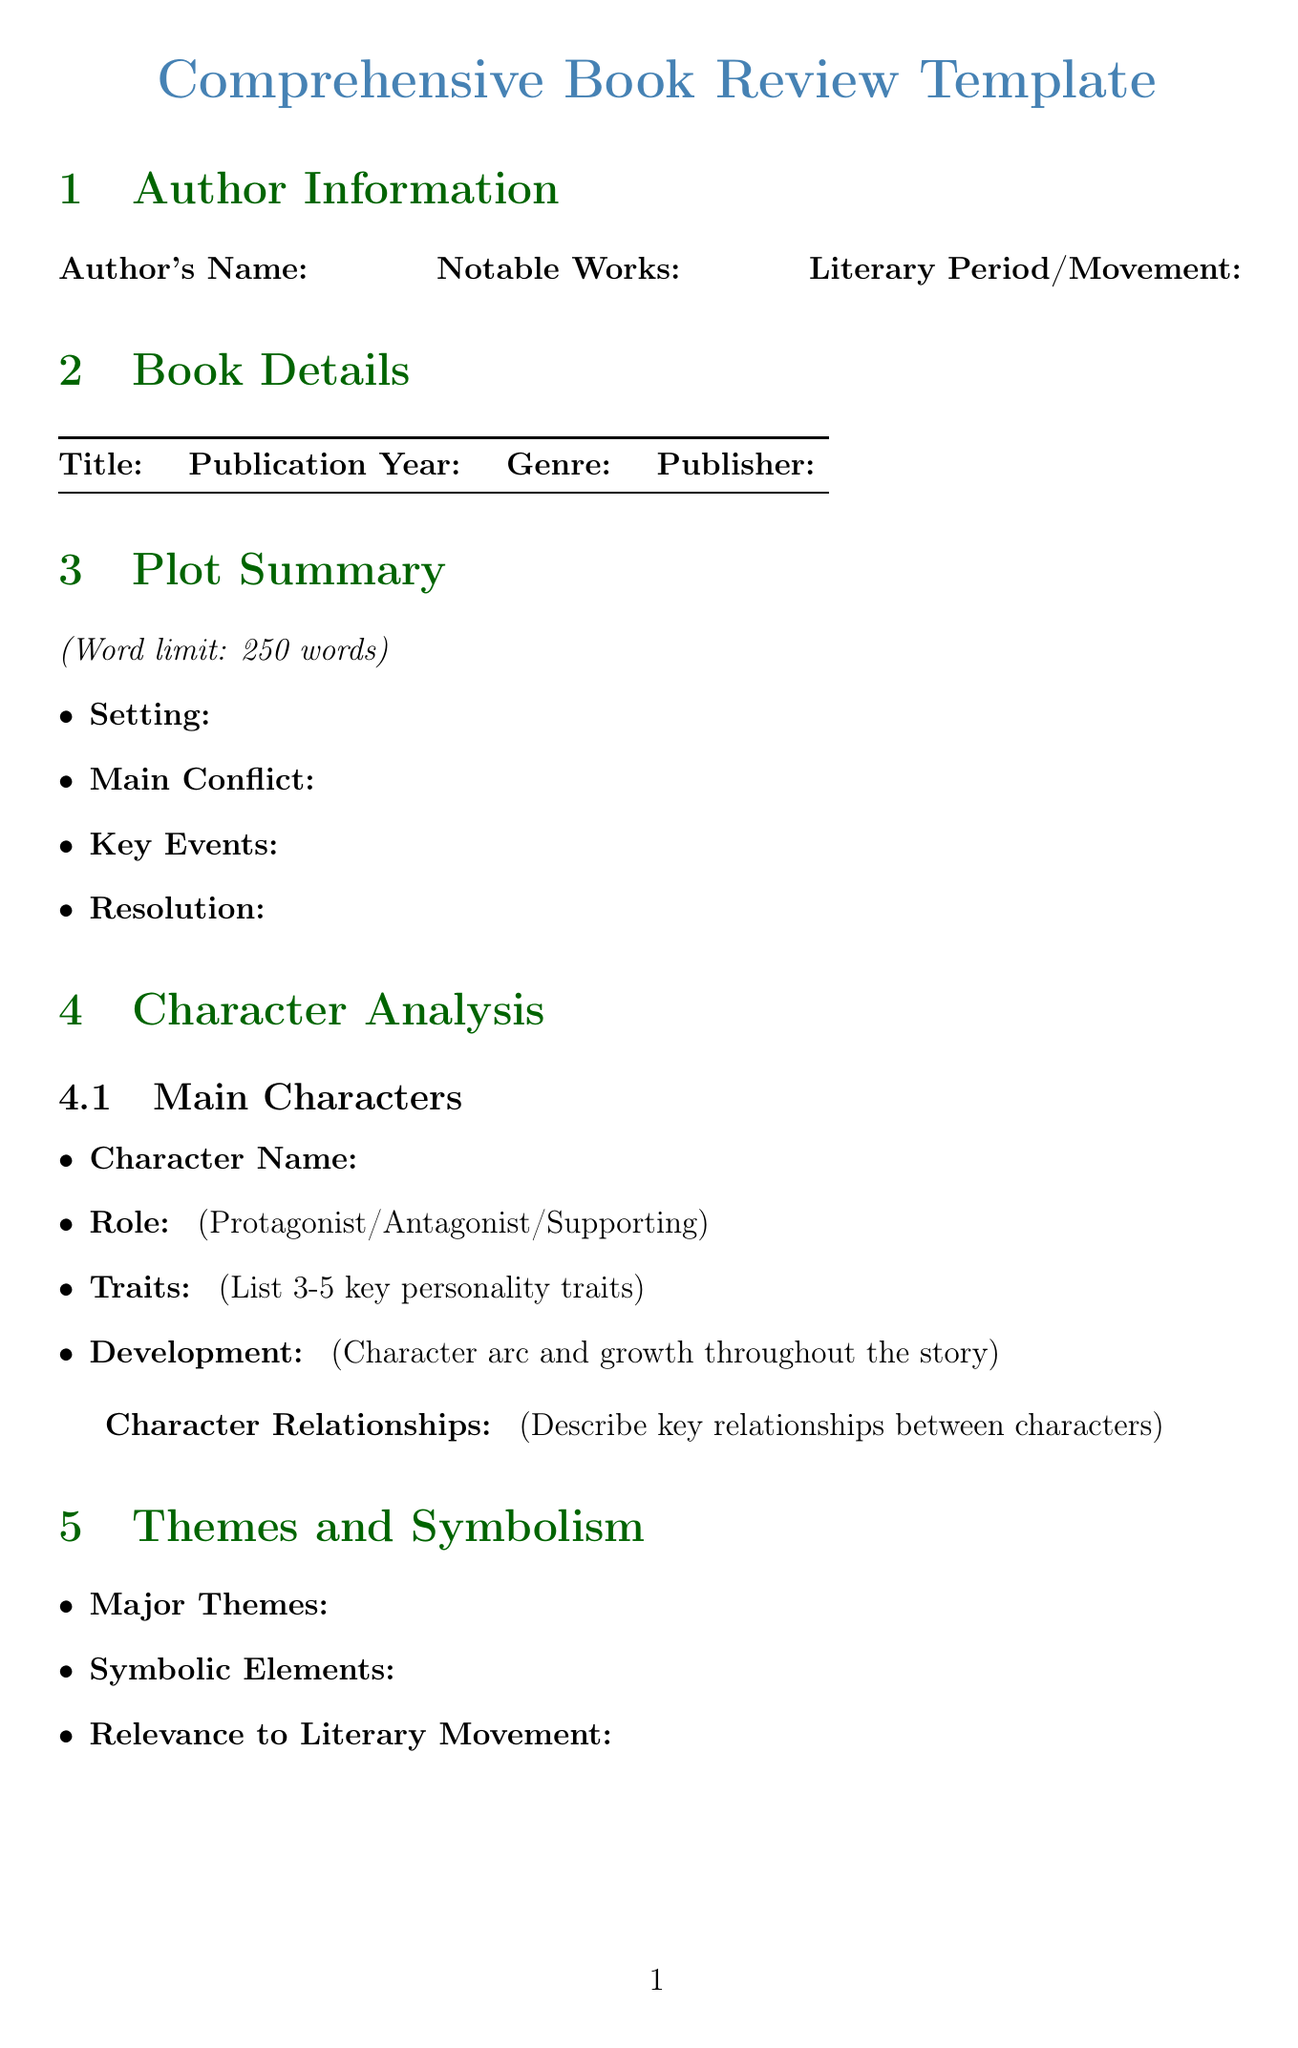what is the title of the document? The title is specified at the top of the document and is "Comprehensive Book Review Template".
Answer: Comprehensive Book Review Template what is the word limit for the plot summary? The word limit is explicitly mentioned in the plot summary section.
Answer: 250 words what section describes character relationships? The section that focuses on character relationships is labeled "Character Analysis".
Answer: Character Analysis how many fields are in the Author Information section? The number of fields listed under Author Information can be counted from the document structure.
Answer: 3 what type of rating scale is used in the Overall Rating section? The type of scale used is indicated clearly in the document under the Overall Rating section.
Answer: 5-star rating which element is included in the Writing Style Analysis section? The Writing Style Analysis section includes various specified elements which are listed.
Answer: Narrative Voice what categories are included in the Further Reading Suggestions section? The categories listed in the Further Reading Suggestions section can be pulled directly from the document.
Answer: Similar Works by the Same Author, Books with Similar Themes, Critical Essays or Analyses on this Work what is one of the prompts in the Personal Reflection section? The Personal Reflection section lists prompts, any of which can be answered.
Answer: Initial reaction to the book what is mentioned as a potential writing prompt under Teaching Applications? The document indicates specific fields under Teaching Applications including potential writing prompts.
Answer: Potential Writing Prompts 